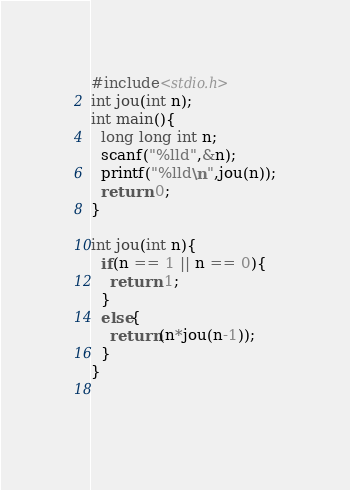Convert code to text. <code><loc_0><loc_0><loc_500><loc_500><_C_>#include<stdio.h>
int jou(int n);
int main(){
  long long int n;
  scanf("%lld",&n);
  printf("%lld\n",jou(n));
  return 0;
}

int jou(int n){
  if(n == 1 || n == 0){
    return 1;
  }
  else{
    return(n*jou(n-1));
  }
}
    
  </code> 